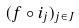<formula> <loc_0><loc_0><loc_500><loc_500>( f \circ i _ { j } ) _ { j \in J }</formula> 